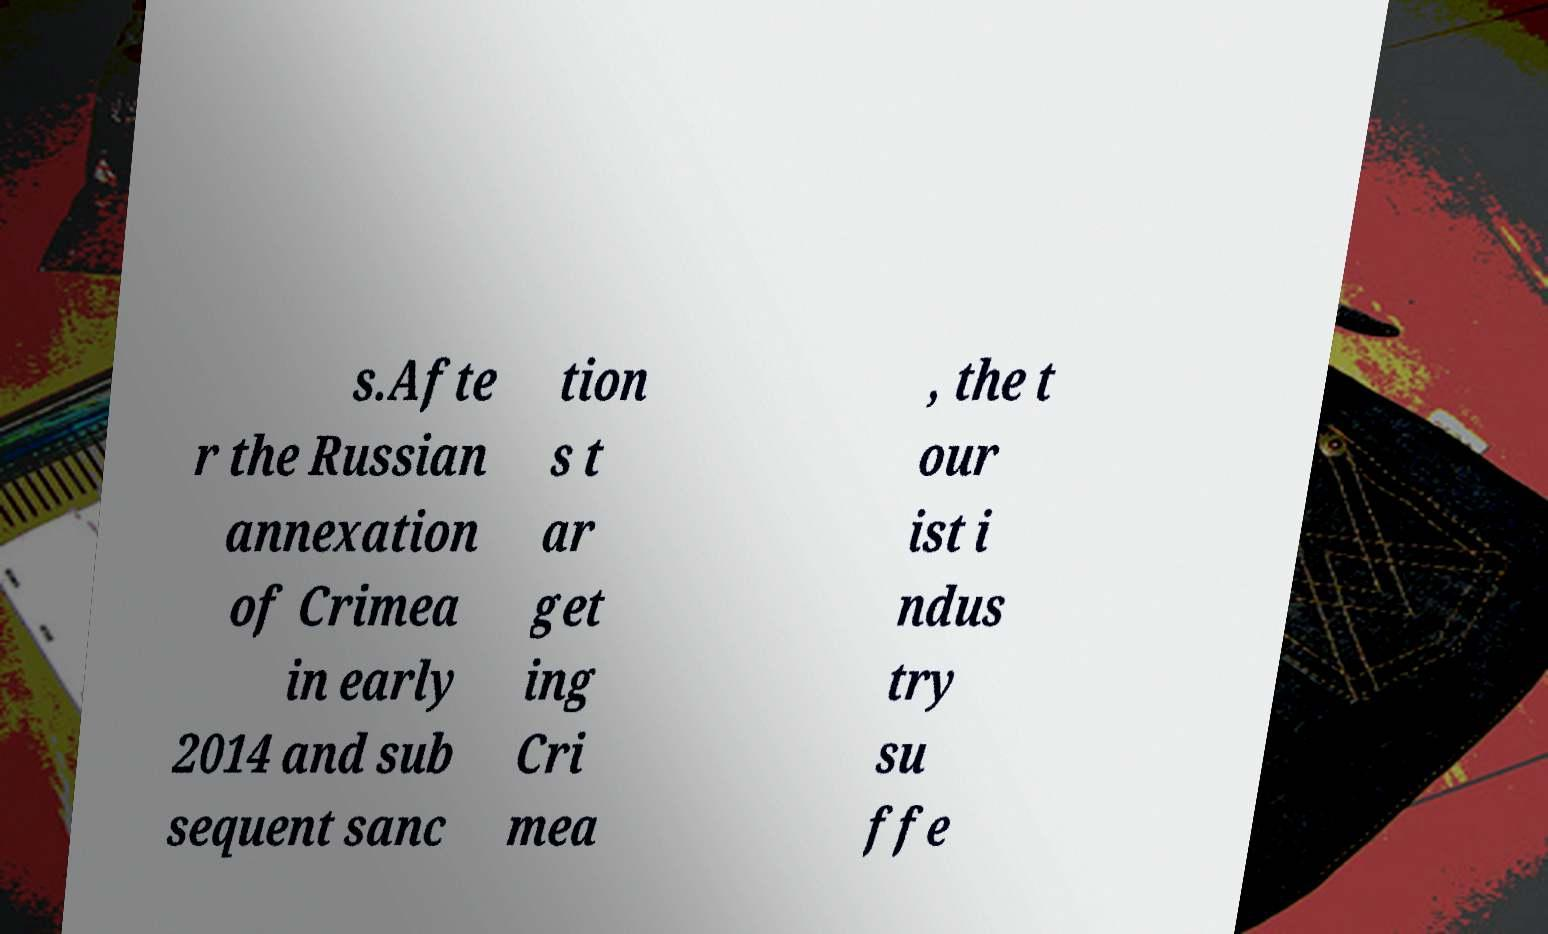What messages or text are displayed in this image? I need them in a readable, typed format. s.Afte r the Russian annexation of Crimea in early 2014 and sub sequent sanc tion s t ar get ing Cri mea , the t our ist i ndus try su ffe 